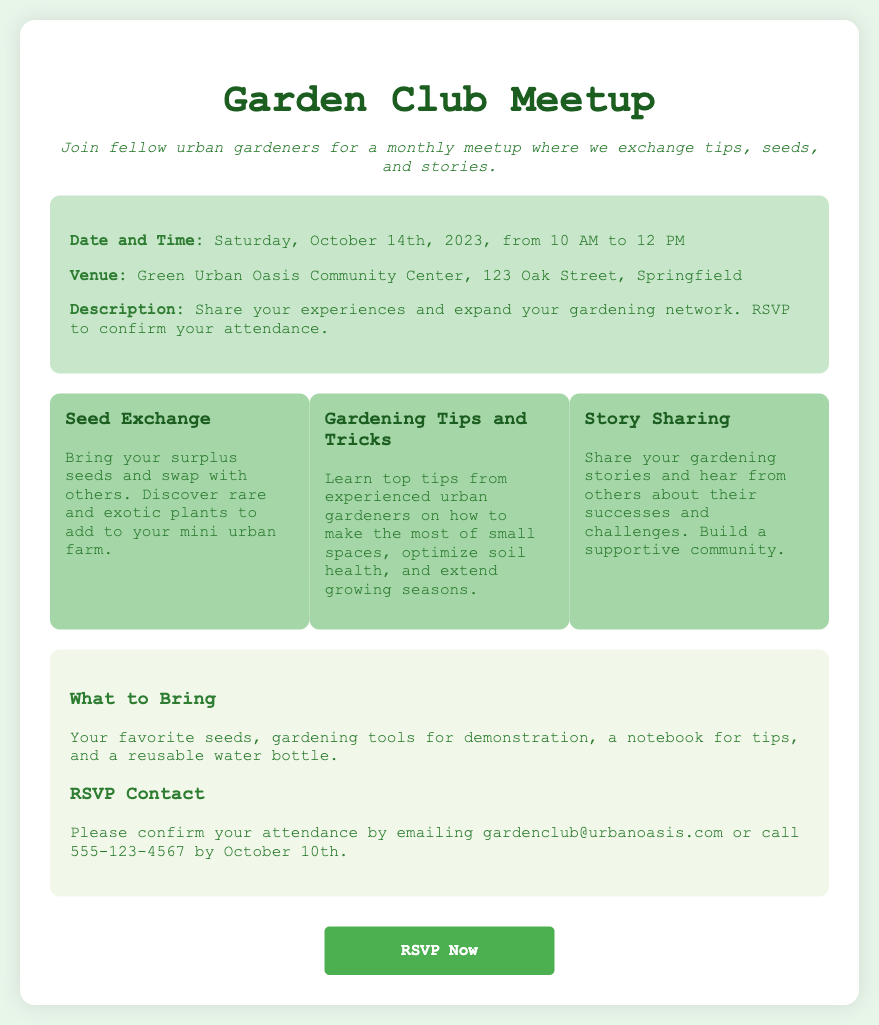What is the date of the meetup? The date of the meetup is explicitly stated in the document.
Answer: Saturday, October 14th, 2023 What is the venue for the meetup? The venue is provided in the details section of the document.
Answer: Green Urban Oasis Community Center What time does the meetup start? The starting time for the meetup is mentioned in the date and time section.
Answer: 10 AM What should participants bring to the meetup? The document specifies what to bring in the additional info section.
Answer: Favorite seeds, gardening tools, a notebook, reusable water bottle How can attendees confirm their presence? The RSVP contact section outlines how to confirm attendance.
Answer: Email or call What is the deadline for RSVPing? The document specifies a deadline for RSVPing in the contact section.
Answer: October 10th What type of exchange will take place during the meetup? The highlights section mentions a specific activity during the meetup.
Answer: Seed Exchange What can attendees learn about from experienced gardeners? Multiple tips on gardening are mentioned in the highlights section.
Answer: Gardening Tips and Tricks What is the theme of the gardening event? The overall purpose of the meetup is found in the tagline and description.
Answer: Exchange tips, seeds, and stories 